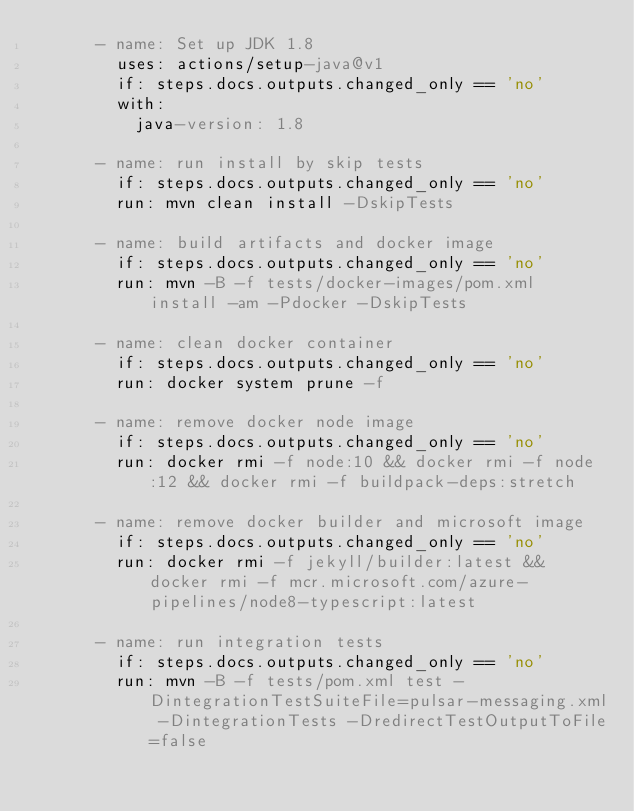Convert code to text. <code><loc_0><loc_0><loc_500><loc_500><_YAML_>      - name: Set up JDK 1.8
        uses: actions/setup-java@v1
        if: steps.docs.outputs.changed_only == 'no'
        with:
          java-version: 1.8

      - name: run install by skip tests
        if: steps.docs.outputs.changed_only == 'no'
        run: mvn clean install -DskipTests

      - name: build artifacts and docker image
        if: steps.docs.outputs.changed_only == 'no'
        run: mvn -B -f tests/docker-images/pom.xml install -am -Pdocker -DskipTests

      - name: clean docker container
        if: steps.docs.outputs.changed_only == 'no'
        run: docker system prune -f

      - name: remove docker node image
        if: steps.docs.outputs.changed_only == 'no'
        run: docker rmi -f node:10 && docker rmi -f node:12 && docker rmi -f buildpack-deps:stretch

      - name: remove docker builder and microsoft image
        if: steps.docs.outputs.changed_only == 'no'
        run: docker rmi -f jekyll/builder:latest && docker rmi -f mcr.microsoft.com/azure-pipelines/node8-typescript:latest

      - name: run integration tests
        if: steps.docs.outputs.changed_only == 'no'
        run: mvn -B -f tests/pom.xml test -DintegrationTestSuiteFile=pulsar-messaging.xml -DintegrationTests -DredirectTestOutputToFile=false
</code> 